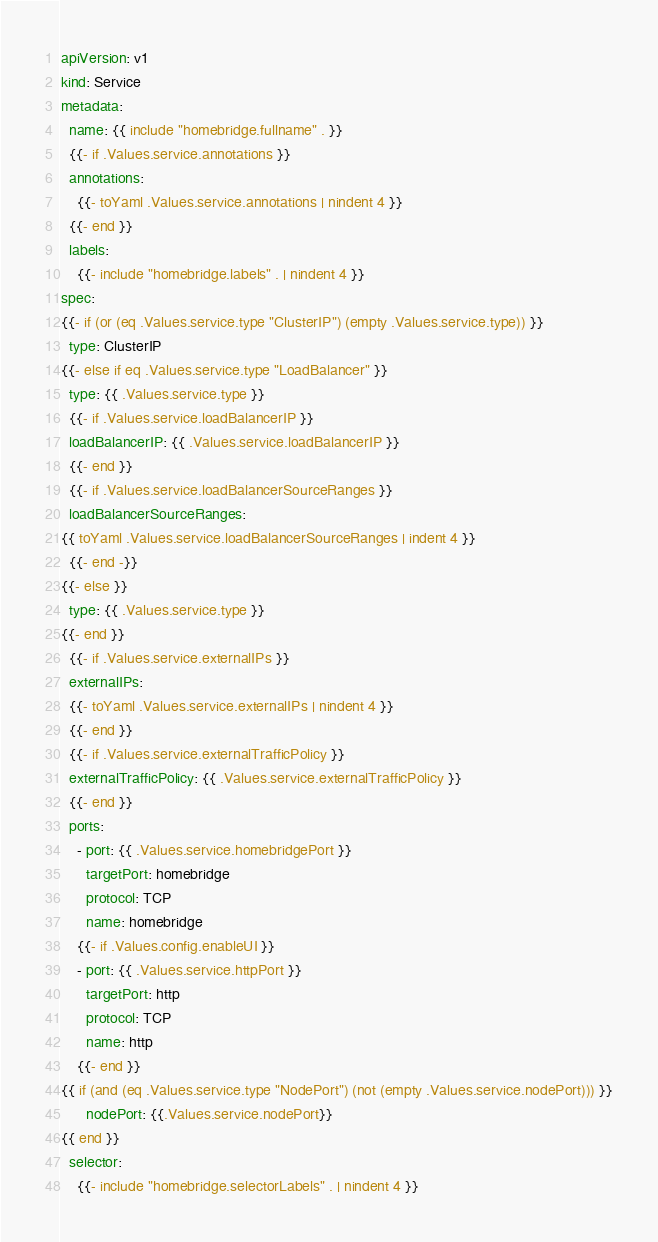Convert code to text. <code><loc_0><loc_0><loc_500><loc_500><_YAML_>apiVersion: v1
kind: Service
metadata:
  name: {{ include "homebridge.fullname" . }}
  {{- if .Values.service.annotations }}
  annotations:
    {{- toYaml .Values.service.annotations | nindent 4 }}
  {{- end }}
  labels:
    {{- include "homebridge.labels" . | nindent 4 }}
spec:
{{- if (or (eq .Values.service.type "ClusterIP") (empty .Values.service.type)) }}
  type: ClusterIP
{{- else if eq .Values.service.type "LoadBalancer" }}
  type: {{ .Values.service.type }}
  {{- if .Values.service.loadBalancerIP }}
  loadBalancerIP: {{ .Values.service.loadBalancerIP }}
  {{- end }}
  {{- if .Values.service.loadBalancerSourceRanges }}
  loadBalancerSourceRanges:
{{ toYaml .Values.service.loadBalancerSourceRanges | indent 4 }}
  {{- end -}}
{{- else }}
  type: {{ .Values.service.type }}
{{- end }}
  {{- if .Values.service.externalIPs }}
  externalIPs:
  {{- toYaml .Values.service.externalIPs | nindent 4 }}
  {{- end }}
  {{- if .Values.service.externalTrafficPolicy }}
  externalTrafficPolicy: {{ .Values.service.externalTrafficPolicy }}
  {{- end }}
  ports:
    - port: {{ .Values.service.homebridgePort }}
      targetPort: homebridge
      protocol: TCP
      name: homebridge
    {{- if .Values.config.enableUI }}
    - port: {{ .Values.service.httpPort }}
      targetPort: http
      protocol: TCP
      name: http
    {{- end }}
{{ if (and (eq .Values.service.type "NodePort") (not (empty .Values.service.nodePort))) }}
      nodePort: {{.Values.service.nodePort}}
{{ end }}
  selector:
    {{- include "homebridge.selectorLabels" . | nindent 4 }}
</code> 